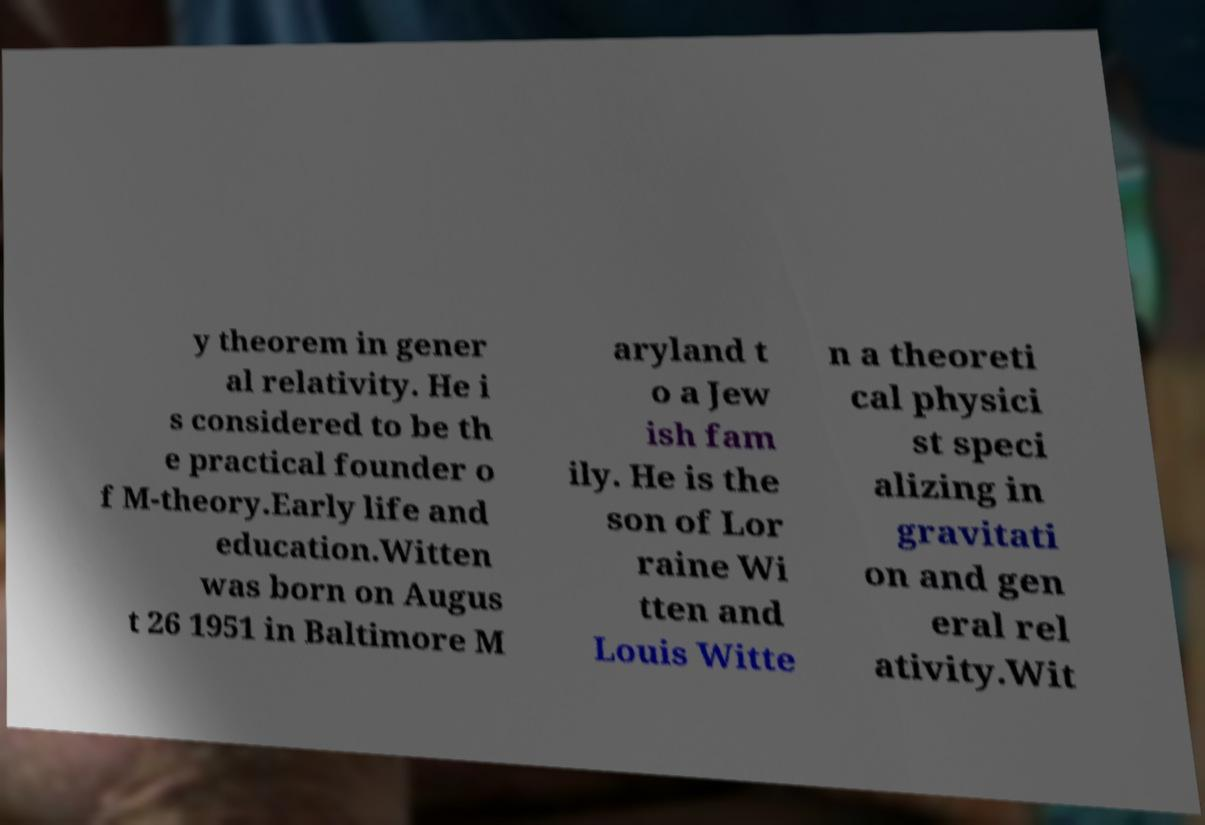Please read and relay the text visible in this image. What does it say? y theorem in gener al relativity. He i s considered to be th e practical founder o f M-theory.Early life and education.Witten was born on Augus t 26 1951 in Baltimore M aryland t o a Jew ish fam ily. He is the son of Lor raine Wi tten and Louis Witte n a theoreti cal physici st speci alizing in gravitati on and gen eral rel ativity.Wit 